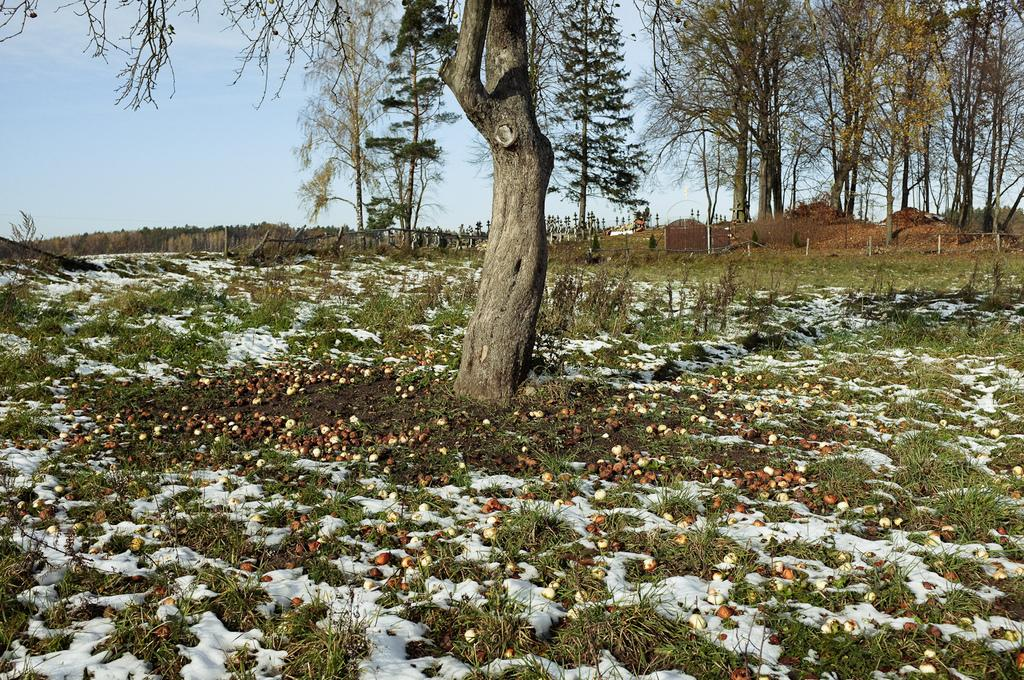What can be seen at the bottom of the image? The ground is visible at the bottom of the image, and snow and grass are also present there. What type of food is in the image? There are fruits in the image. What is visible in the background of the image? Trees are present in the background of the image. What is visible at the top of the image? The sky is visible at the top of the image. What type of ink is used to write on the body in the image? There is no body or writing present in the image; it features snow, grass, fruits, trees, and the sky. 